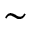Convert formula to latex. <formula><loc_0><loc_0><loc_500><loc_500>\sim</formula> 